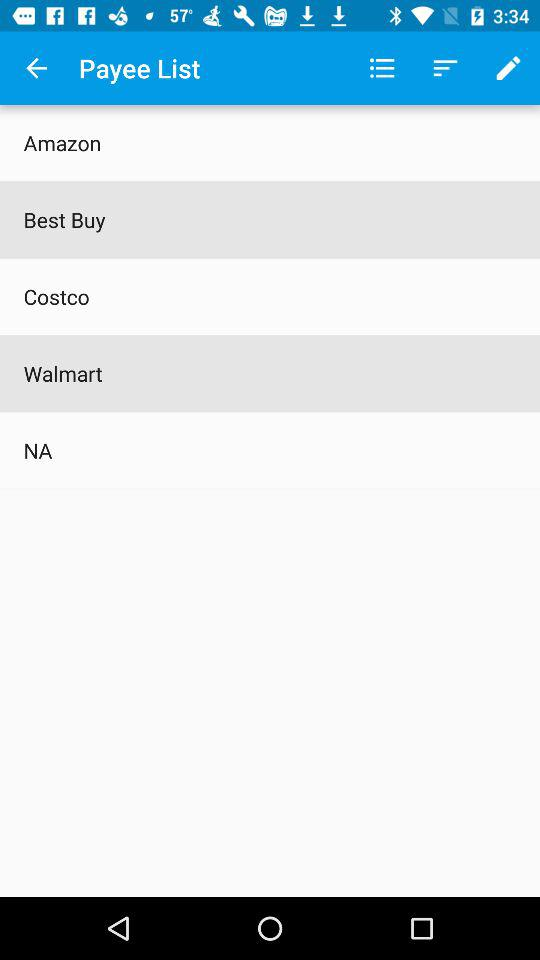How many payees are there?
Answer the question using a single word or phrase. 5 